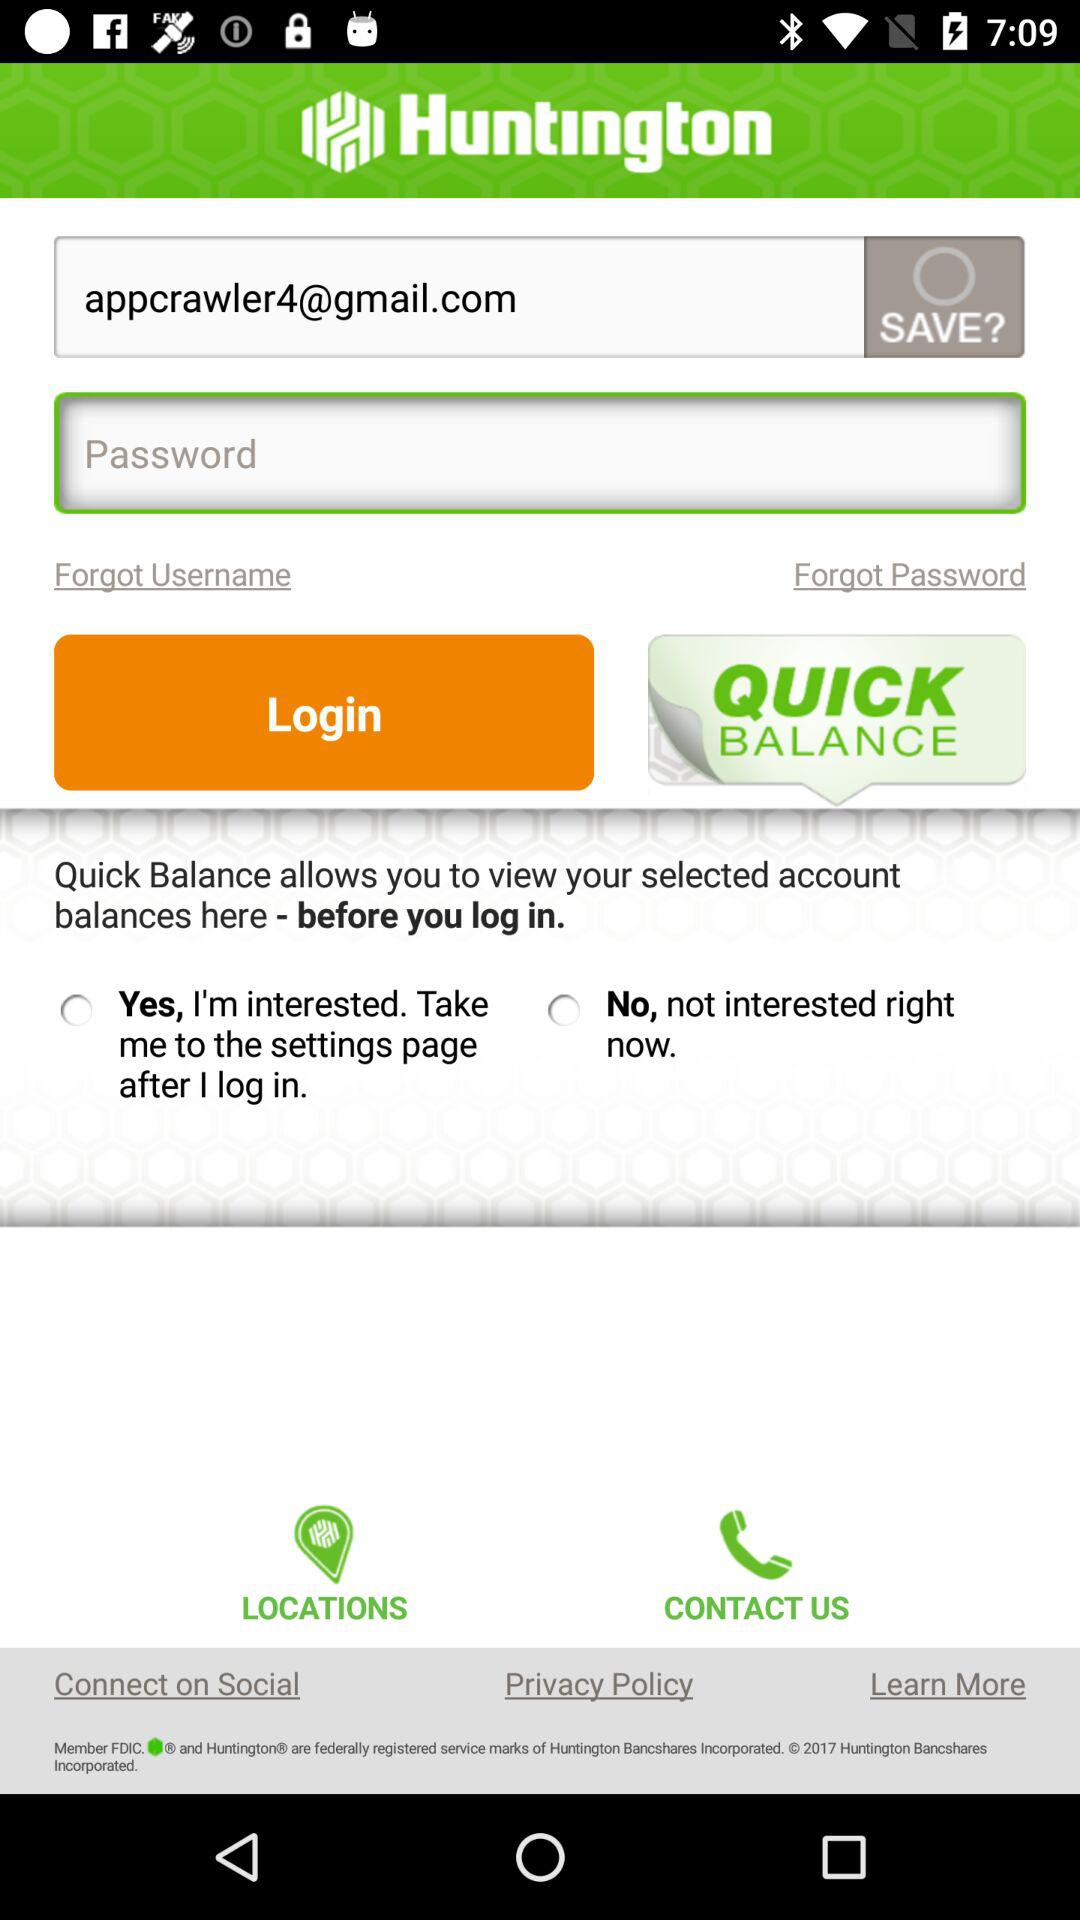What is the application name? The application name is "Huntington". 